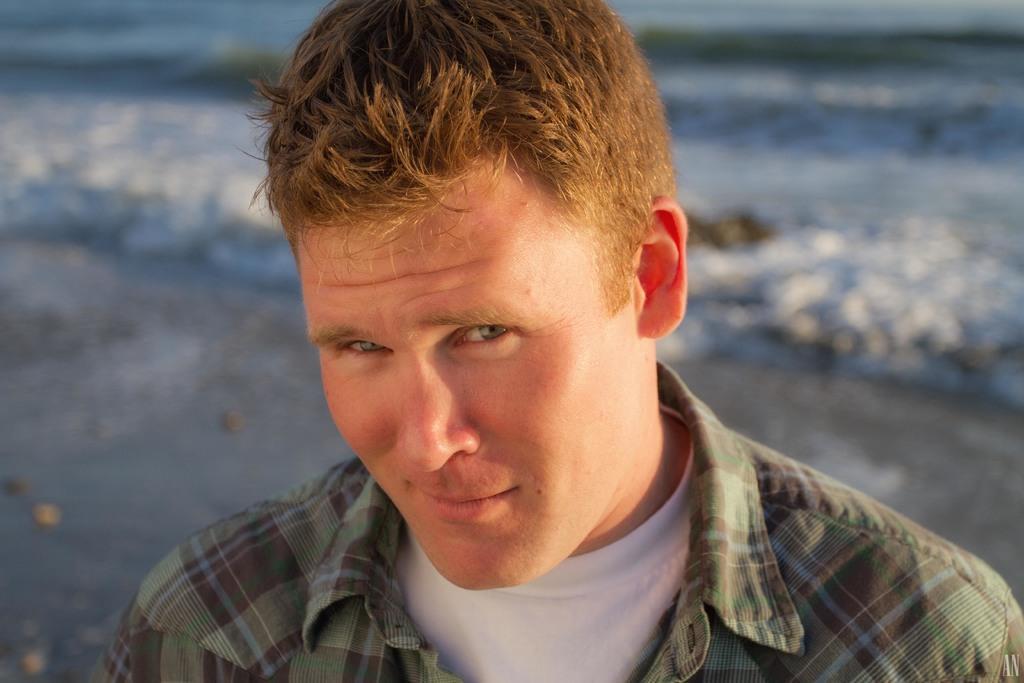Can you describe this image briefly? In this image we can see a man. 